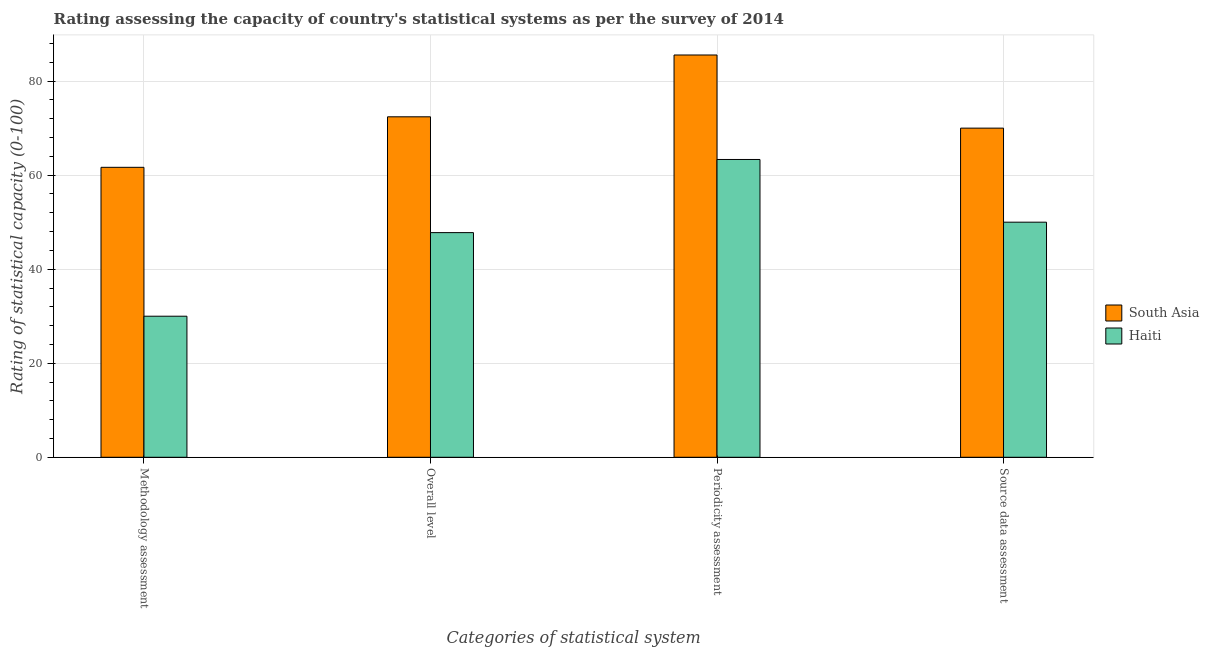How many groups of bars are there?
Offer a very short reply. 4. How many bars are there on the 4th tick from the right?
Ensure brevity in your answer.  2. What is the label of the 1st group of bars from the left?
Your response must be concise. Methodology assessment. Across all countries, what is the maximum periodicity assessment rating?
Make the answer very short. 85.56. In which country was the methodology assessment rating minimum?
Your answer should be compact. Haiti. What is the total source data assessment rating in the graph?
Provide a succinct answer. 120. What is the difference between the overall level rating in South Asia and that in Haiti?
Your response must be concise. 24.63. What is the difference between the periodicity assessment rating in Haiti and the source data assessment rating in South Asia?
Your response must be concise. -6.67. What is the average methodology assessment rating per country?
Give a very brief answer. 45.83. What is the difference between the periodicity assessment rating and overall level rating in Haiti?
Make the answer very short. 15.56. What is the ratio of the overall level rating in South Asia to that in Haiti?
Your answer should be compact. 1.52. What is the difference between the highest and the lowest methodology assessment rating?
Your answer should be very brief. 31.67. Is the sum of the periodicity assessment rating in South Asia and Haiti greater than the maximum overall level rating across all countries?
Keep it short and to the point. Yes. Is it the case that in every country, the sum of the periodicity assessment rating and overall level rating is greater than the sum of methodology assessment rating and source data assessment rating?
Offer a very short reply. No. What does the 2nd bar from the left in Overall level represents?
Your answer should be compact. Haiti. What does the 1st bar from the right in Periodicity assessment represents?
Your answer should be compact. Haiti. Is it the case that in every country, the sum of the methodology assessment rating and overall level rating is greater than the periodicity assessment rating?
Your response must be concise. Yes. How many bars are there?
Your response must be concise. 8. How many countries are there in the graph?
Make the answer very short. 2. What is the title of the graph?
Your answer should be compact. Rating assessing the capacity of country's statistical systems as per the survey of 2014 . Does "Virgin Islands" appear as one of the legend labels in the graph?
Provide a short and direct response. No. What is the label or title of the X-axis?
Provide a short and direct response. Categories of statistical system. What is the label or title of the Y-axis?
Make the answer very short. Rating of statistical capacity (0-100). What is the Rating of statistical capacity (0-100) in South Asia in Methodology assessment?
Make the answer very short. 61.67. What is the Rating of statistical capacity (0-100) of Haiti in Methodology assessment?
Make the answer very short. 30. What is the Rating of statistical capacity (0-100) in South Asia in Overall level?
Provide a short and direct response. 72.41. What is the Rating of statistical capacity (0-100) in Haiti in Overall level?
Your response must be concise. 47.78. What is the Rating of statistical capacity (0-100) of South Asia in Periodicity assessment?
Your answer should be compact. 85.56. What is the Rating of statistical capacity (0-100) of Haiti in Periodicity assessment?
Your answer should be compact. 63.33. What is the Rating of statistical capacity (0-100) of South Asia in Source data assessment?
Ensure brevity in your answer.  70. What is the Rating of statistical capacity (0-100) in Haiti in Source data assessment?
Keep it short and to the point. 50. Across all Categories of statistical system, what is the maximum Rating of statistical capacity (0-100) of South Asia?
Ensure brevity in your answer.  85.56. Across all Categories of statistical system, what is the maximum Rating of statistical capacity (0-100) of Haiti?
Keep it short and to the point. 63.33. Across all Categories of statistical system, what is the minimum Rating of statistical capacity (0-100) of South Asia?
Give a very brief answer. 61.67. What is the total Rating of statistical capacity (0-100) of South Asia in the graph?
Make the answer very short. 289.63. What is the total Rating of statistical capacity (0-100) of Haiti in the graph?
Provide a short and direct response. 191.11. What is the difference between the Rating of statistical capacity (0-100) in South Asia in Methodology assessment and that in Overall level?
Ensure brevity in your answer.  -10.74. What is the difference between the Rating of statistical capacity (0-100) of Haiti in Methodology assessment and that in Overall level?
Make the answer very short. -17.78. What is the difference between the Rating of statistical capacity (0-100) of South Asia in Methodology assessment and that in Periodicity assessment?
Make the answer very short. -23.89. What is the difference between the Rating of statistical capacity (0-100) in Haiti in Methodology assessment and that in Periodicity assessment?
Give a very brief answer. -33.33. What is the difference between the Rating of statistical capacity (0-100) in South Asia in Methodology assessment and that in Source data assessment?
Keep it short and to the point. -8.33. What is the difference between the Rating of statistical capacity (0-100) of South Asia in Overall level and that in Periodicity assessment?
Offer a very short reply. -13.15. What is the difference between the Rating of statistical capacity (0-100) of Haiti in Overall level and that in Periodicity assessment?
Your response must be concise. -15.56. What is the difference between the Rating of statistical capacity (0-100) in South Asia in Overall level and that in Source data assessment?
Your response must be concise. 2.41. What is the difference between the Rating of statistical capacity (0-100) of Haiti in Overall level and that in Source data assessment?
Your answer should be very brief. -2.22. What is the difference between the Rating of statistical capacity (0-100) in South Asia in Periodicity assessment and that in Source data assessment?
Make the answer very short. 15.56. What is the difference between the Rating of statistical capacity (0-100) of Haiti in Periodicity assessment and that in Source data assessment?
Keep it short and to the point. 13.33. What is the difference between the Rating of statistical capacity (0-100) of South Asia in Methodology assessment and the Rating of statistical capacity (0-100) of Haiti in Overall level?
Your answer should be compact. 13.89. What is the difference between the Rating of statistical capacity (0-100) of South Asia in Methodology assessment and the Rating of statistical capacity (0-100) of Haiti in Periodicity assessment?
Your response must be concise. -1.67. What is the difference between the Rating of statistical capacity (0-100) in South Asia in Methodology assessment and the Rating of statistical capacity (0-100) in Haiti in Source data assessment?
Provide a short and direct response. 11.67. What is the difference between the Rating of statistical capacity (0-100) in South Asia in Overall level and the Rating of statistical capacity (0-100) in Haiti in Periodicity assessment?
Provide a succinct answer. 9.07. What is the difference between the Rating of statistical capacity (0-100) in South Asia in Overall level and the Rating of statistical capacity (0-100) in Haiti in Source data assessment?
Your response must be concise. 22.41. What is the difference between the Rating of statistical capacity (0-100) of South Asia in Periodicity assessment and the Rating of statistical capacity (0-100) of Haiti in Source data assessment?
Offer a terse response. 35.56. What is the average Rating of statistical capacity (0-100) in South Asia per Categories of statistical system?
Make the answer very short. 72.41. What is the average Rating of statistical capacity (0-100) in Haiti per Categories of statistical system?
Your response must be concise. 47.78. What is the difference between the Rating of statistical capacity (0-100) in South Asia and Rating of statistical capacity (0-100) in Haiti in Methodology assessment?
Ensure brevity in your answer.  31.67. What is the difference between the Rating of statistical capacity (0-100) of South Asia and Rating of statistical capacity (0-100) of Haiti in Overall level?
Provide a short and direct response. 24.63. What is the difference between the Rating of statistical capacity (0-100) in South Asia and Rating of statistical capacity (0-100) in Haiti in Periodicity assessment?
Offer a terse response. 22.22. What is the ratio of the Rating of statistical capacity (0-100) of South Asia in Methodology assessment to that in Overall level?
Keep it short and to the point. 0.85. What is the ratio of the Rating of statistical capacity (0-100) in Haiti in Methodology assessment to that in Overall level?
Offer a terse response. 0.63. What is the ratio of the Rating of statistical capacity (0-100) in South Asia in Methodology assessment to that in Periodicity assessment?
Ensure brevity in your answer.  0.72. What is the ratio of the Rating of statistical capacity (0-100) in Haiti in Methodology assessment to that in Periodicity assessment?
Offer a very short reply. 0.47. What is the ratio of the Rating of statistical capacity (0-100) of South Asia in Methodology assessment to that in Source data assessment?
Provide a succinct answer. 0.88. What is the ratio of the Rating of statistical capacity (0-100) of South Asia in Overall level to that in Periodicity assessment?
Offer a terse response. 0.85. What is the ratio of the Rating of statistical capacity (0-100) of Haiti in Overall level to that in Periodicity assessment?
Keep it short and to the point. 0.75. What is the ratio of the Rating of statistical capacity (0-100) in South Asia in Overall level to that in Source data assessment?
Offer a very short reply. 1.03. What is the ratio of the Rating of statistical capacity (0-100) of Haiti in Overall level to that in Source data assessment?
Offer a terse response. 0.96. What is the ratio of the Rating of statistical capacity (0-100) in South Asia in Periodicity assessment to that in Source data assessment?
Make the answer very short. 1.22. What is the ratio of the Rating of statistical capacity (0-100) of Haiti in Periodicity assessment to that in Source data assessment?
Offer a very short reply. 1.27. What is the difference between the highest and the second highest Rating of statistical capacity (0-100) of South Asia?
Offer a very short reply. 13.15. What is the difference between the highest and the second highest Rating of statistical capacity (0-100) in Haiti?
Offer a terse response. 13.33. What is the difference between the highest and the lowest Rating of statistical capacity (0-100) in South Asia?
Your answer should be very brief. 23.89. What is the difference between the highest and the lowest Rating of statistical capacity (0-100) in Haiti?
Provide a succinct answer. 33.33. 